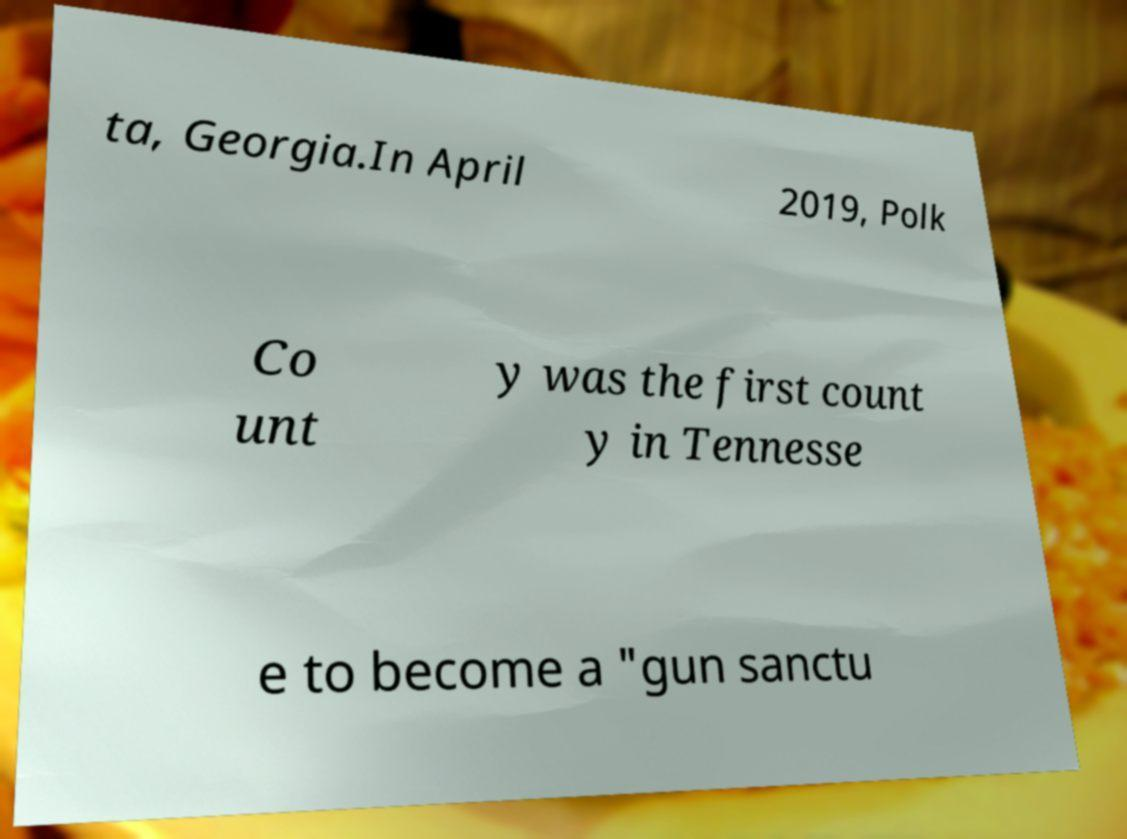There's text embedded in this image that I need extracted. Can you transcribe it verbatim? ta, Georgia.In April 2019, Polk Co unt y was the first count y in Tennesse e to become a "gun sanctu 